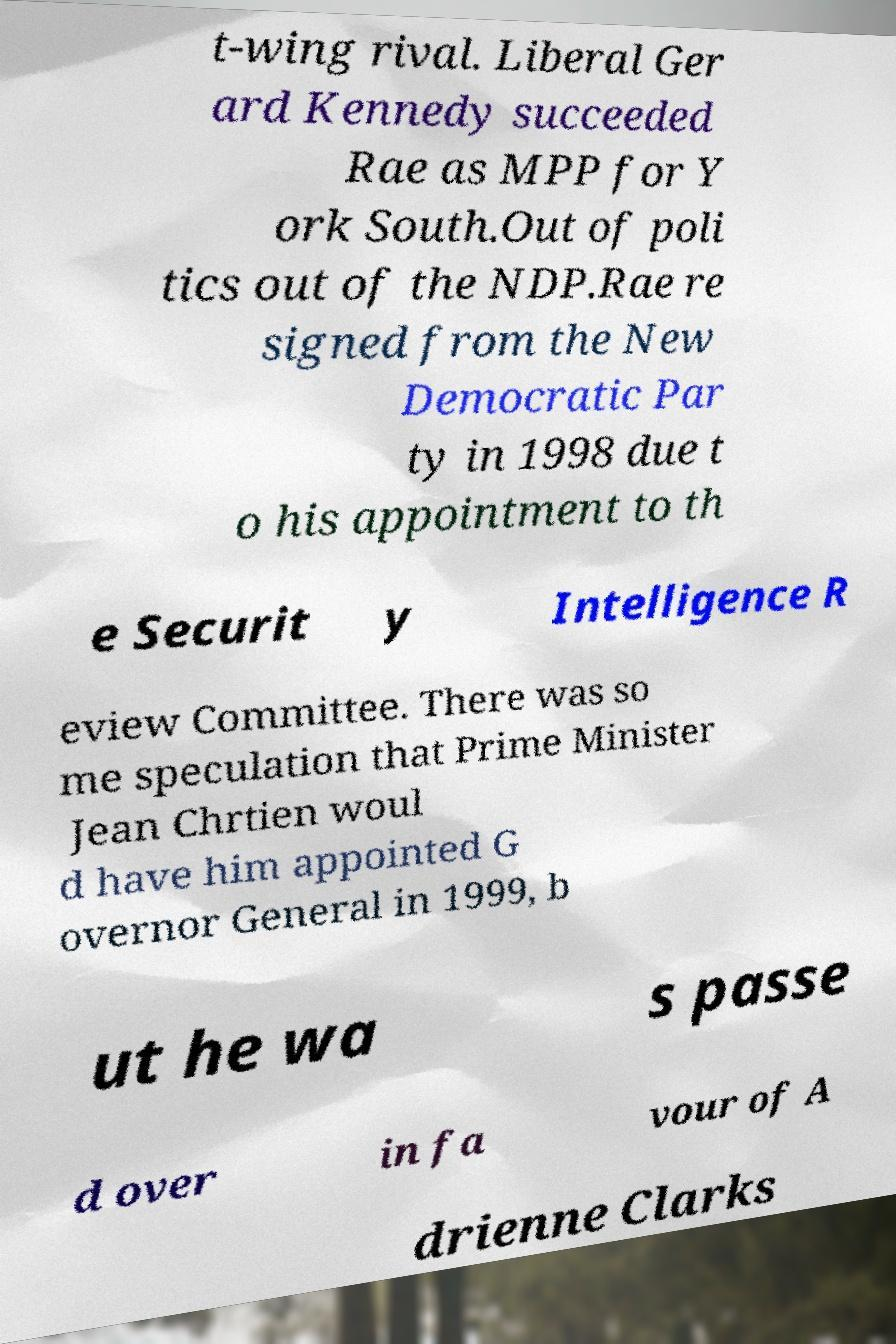Please read and relay the text visible in this image. What does it say? t-wing rival. Liberal Ger ard Kennedy succeeded Rae as MPP for Y ork South.Out of poli tics out of the NDP.Rae re signed from the New Democratic Par ty in 1998 due t o his appointment to th e Securit y Intelligence R eview Committee. There was so me speculation that Prime Minister Jean Chrtien woul d have him appointed G overnor General in 1999, b ut he wa s passe d over in fa vour of A drienne Clarks 